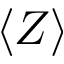Convert formula to latex. <formula><loc_0><loc_0><loc_500><loc_500>\langle Z \rangle</formula> 